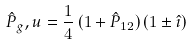<formula> <loc_0><loc_0><loc_500><loc_500>\hat { P } _ { g } , u = \frac { 1 } { 4 } \, ( 1 + \hat { P } _ { 1 2 } ) \, ( 1 \pm \hat { \imath } )</formula> 